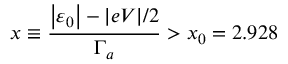<formula> <loc_0><loc_0><loc_500><loc_500>x \equiv \frac { \left | \varepsilon _ { 0 } \right | - | e V | / 2 } { \Gamma _ { a } } > x _ { 0 } = 2 . 9 2 8</formula> 